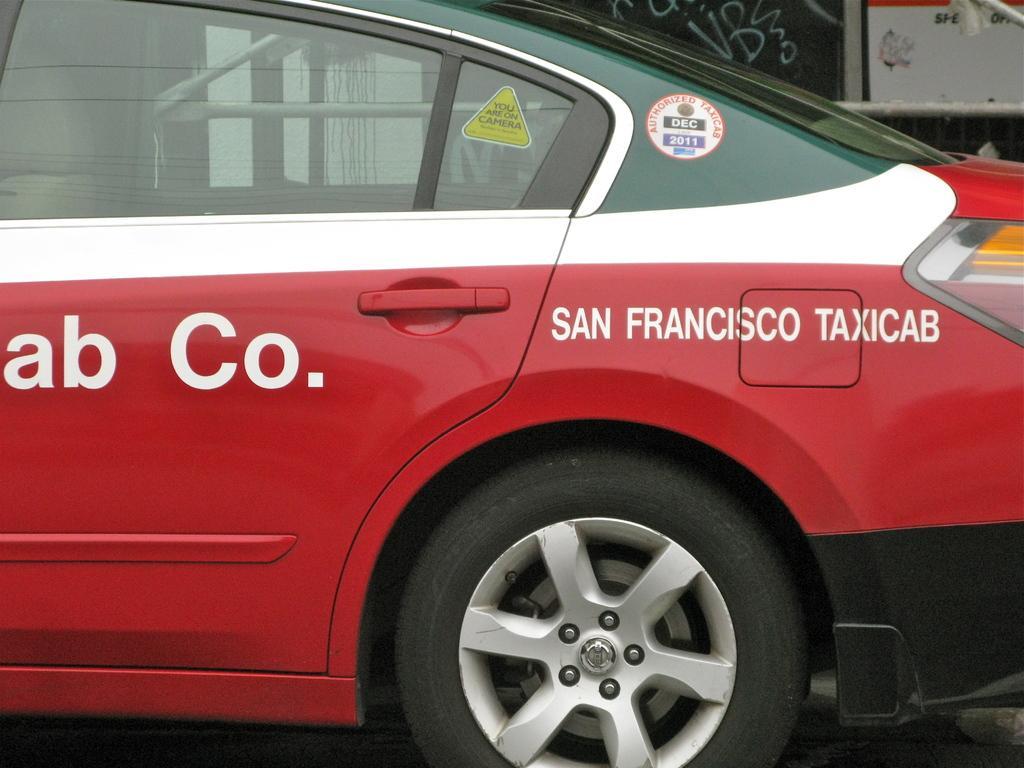Could you give a brief overview of what you see in this image? There is a green, white and red car on which something is written. 